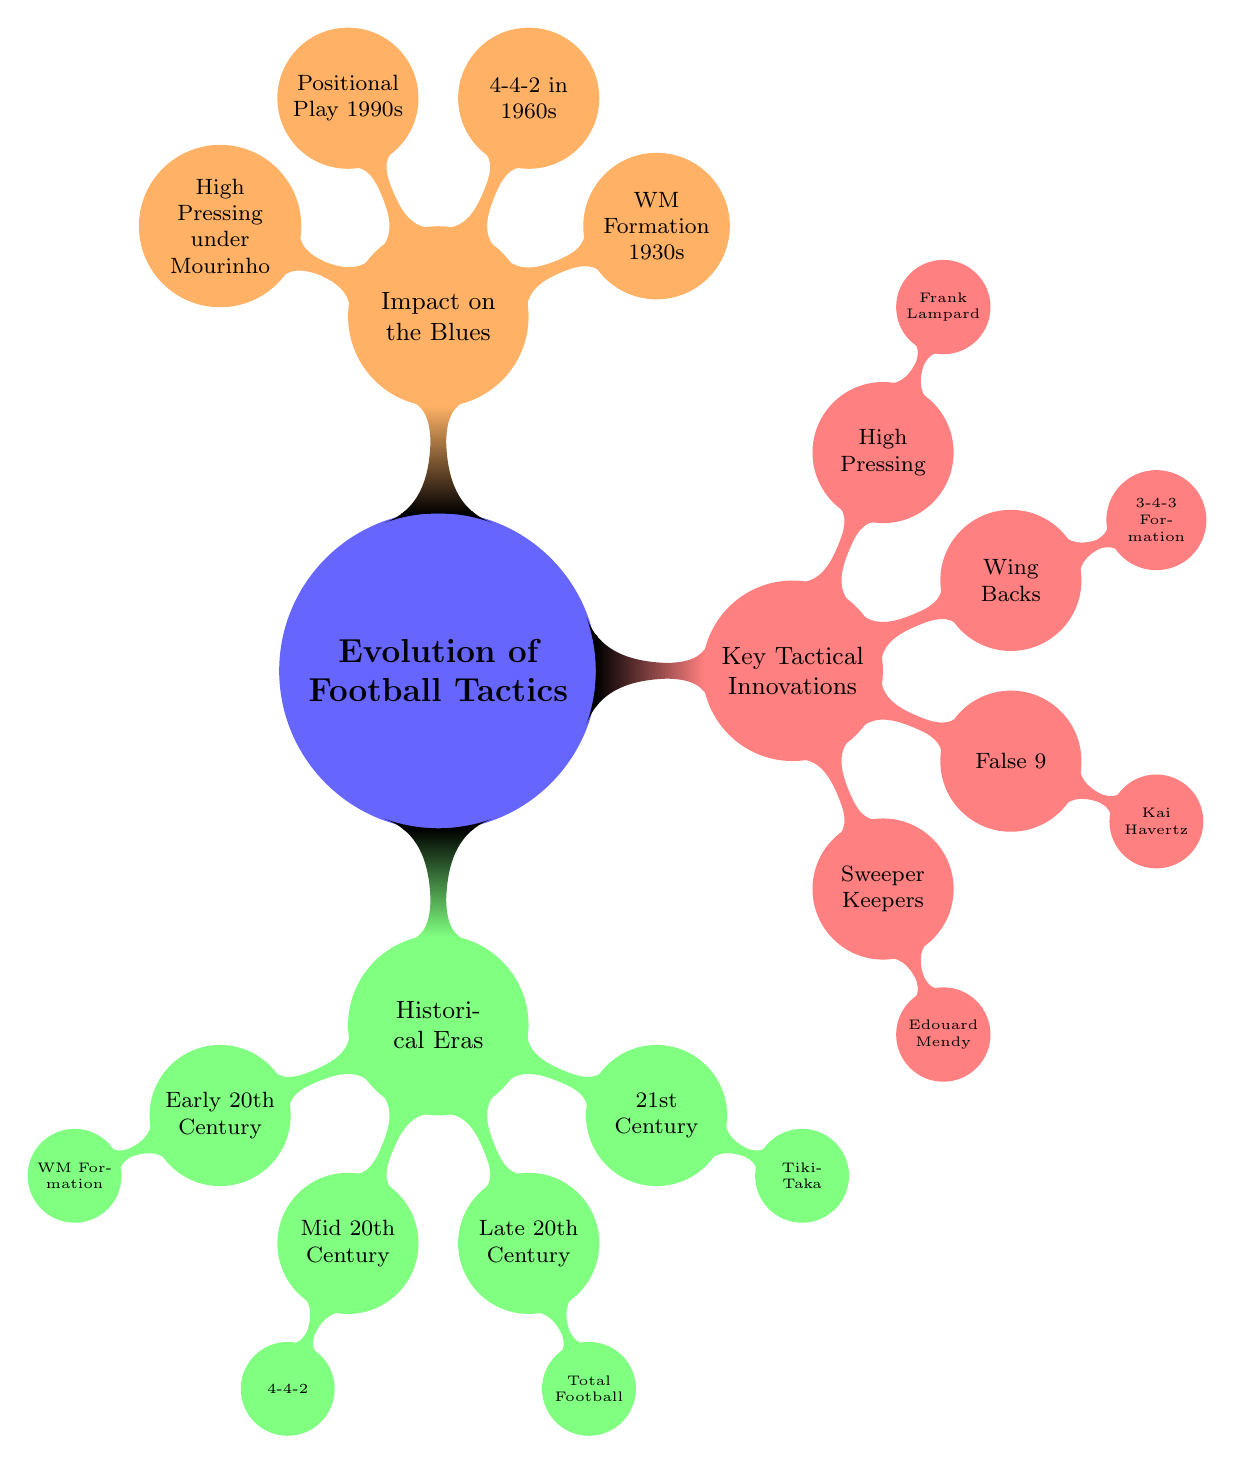What primary tactic was used in the Early 20th Century? The diagram shows that the primary tactics during the Early 20th Century included "2-3-5" and "WM Formation". The first primary tactic mentioned is "2-3-5".
Answer: 2-3-5 Who was a notable manager during the Mid 20th Century? In the Mid 20th Century section of the diagram, "Helenio Herrera" is listed as a notable manager.
Answer: Helenio Herrera What tactic did the Blues shift to in the 1960s? The diagram indicates that the Blues shifted to the "4-4-2" tactic in the 1960s, as seen under the Mid 20th Century section.
Answer: 4-4-2 Which tactical innovation is associated with Frank Lampard? The diagram states that "High Pressing" is employed by Frank Lampard, showing the connection between the tactical innovation and the manager.
Answer: High Pressing What is the key impact of the WM Formation on the Blues? The diagram notes that the impact on the Blues of the WM Formation was its adoption in the 1930s, establishing a historical connection.
Answer: Adoption of WM Formation in the 1930s Which tactic introduced High Pressing under a prominent manager? The diagram identifies that High Pressing was introduced under José Mourinho in the 21st Century. So while asking for the introduction context, the response identifies José Mourinho.
Answer: José Mourinho How are "False 9" players utilized in the context of the Blues? Based on the diagram, the role of "False 9" is exemplified by Kai Havertz under Thomas Tuchel, showing the application of the tactic within the team.
Answer: Kai Havertz What important tactical contribution did Edouard Mendy represent? The diagram links Edouard Mendy to the tactical innovation of "Sweeper Keepers", highlighting his role within that context.
Answer: Role of Edouard Mendy 